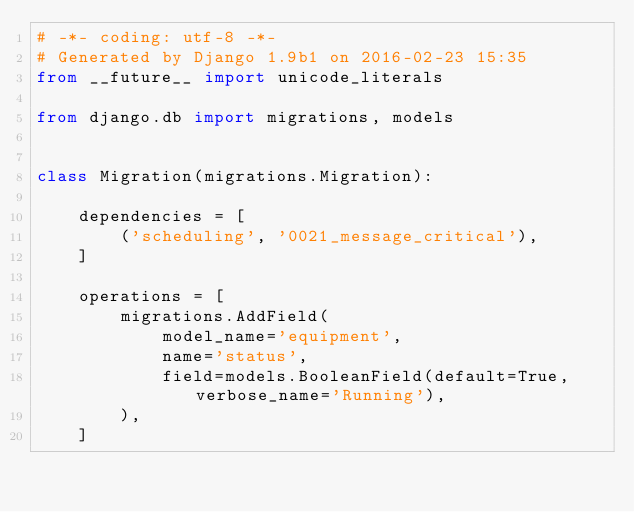Convert code to text. <code><loc_0><loc_0><loc_500><loc_500><_Python_># -*- coding: utf-8 -*-
# Generated by Django 1.9b1 on 2016-02-23 15:35
from __future__ import unicode_literals

from django.db import migrations, models


class Migration(migrations.Migration):

    dependencies = [
        ('scheduling', '0021_message_critical'),
    ]

    operations = [
        migrations.AddField(
            model_name='equipment',
            name='status',
            field=models.BooleanField(default=True, verbose_name='Running'),
        ),
    ]
</code> 